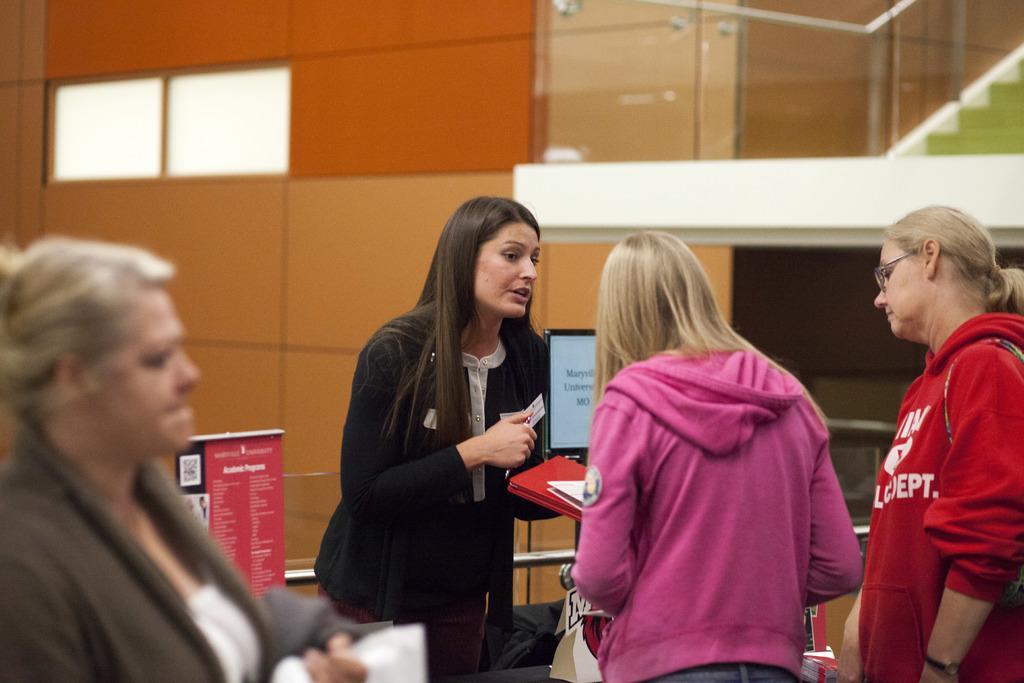Describe this image in one or two sentences. In this image I can see the group of people with different color dresses. In-front of one person I can see the system. In the back there is a red color banner. In the back I can see the wall and the glass railing. 